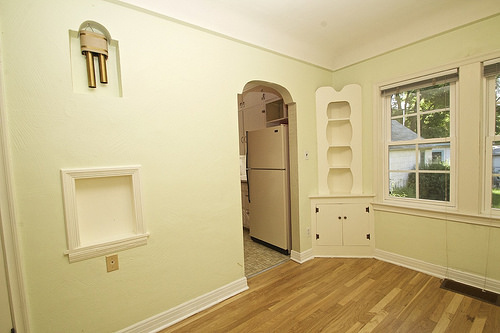<image>
Can you confirm if the window is to the left of the doorway? No. The window is not to the left of the doorway. From this viewpoint, they have a different horizontal relationship. Where is the bell in relation to the wall? Is it above the wall? No. The bell is not positioned above the wall. The vertical arrangement shows a different relationship. 